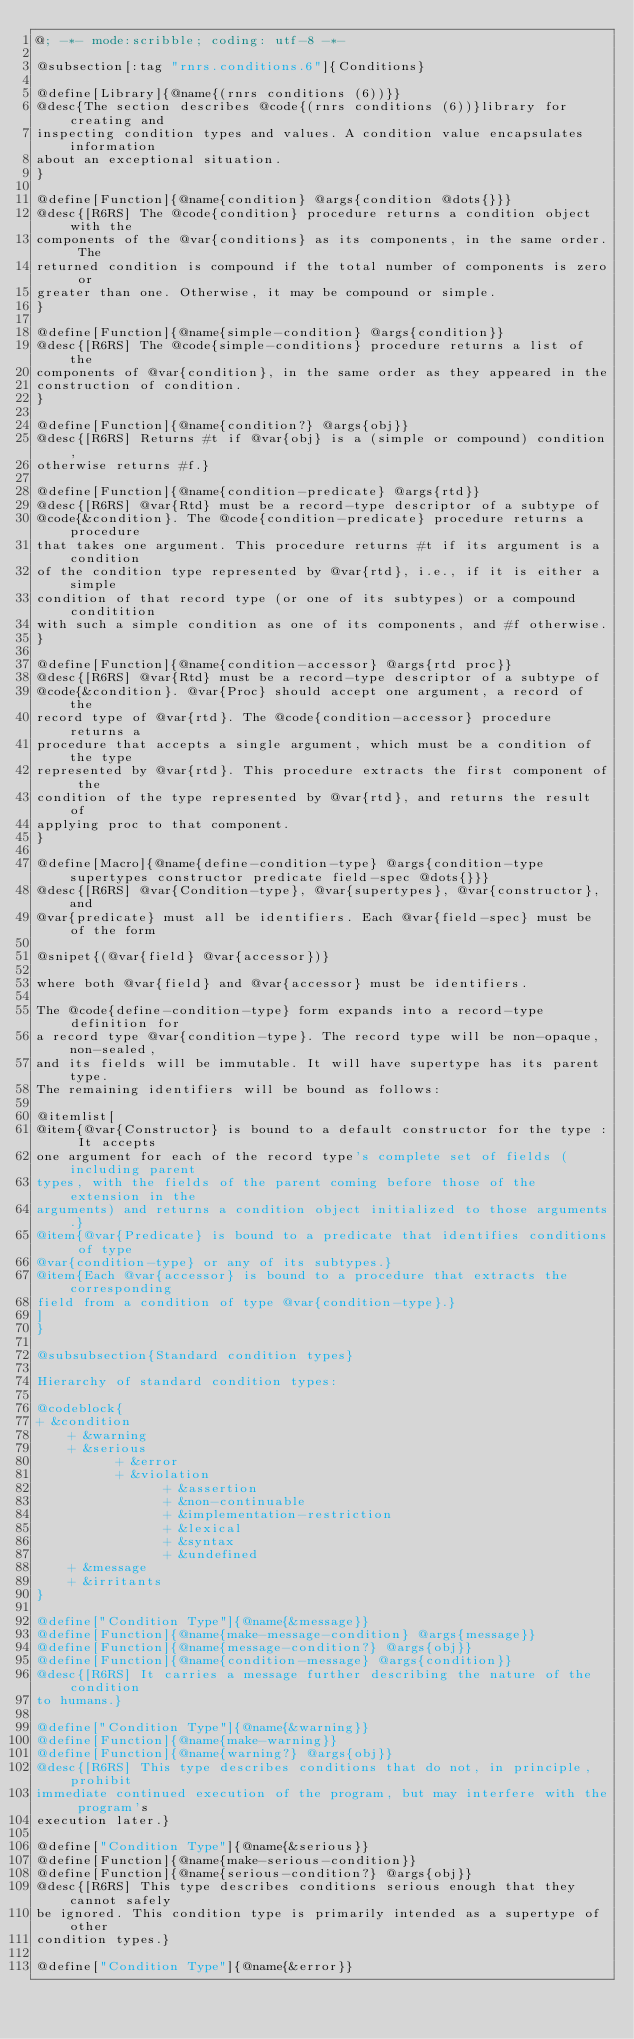<code> <loc_0><loc_0><loc_500><loc_500><_Racket_>@; -*- mode:scribble; coding: utf-8 -*-

@subsection[:tag "rnrs.conditions.6"]{Conditions}

@define[Library]{@name{(rnrs conditions (6))}}
@desc{The section describes @code{(rnrs conditions (6))}library for creating and
inspecting condition types and values. A condition value encapsulates information
about an exceptional situation.
}

@define[Function]{@name{condition} @args{condition @dots{}}}
@desc{[R6RS] The @code{condition} procedure returns a condition object with the
components of the @var{conditions} as its components, in the same order. The
returned condition is compound if the total number of components is zero or
greater than one. Otherwise, it may be compound or simple.
}

@define[Function]{@name{simple-condition} @args{condition}}
@desc{[R6RS] The @code{simple-conditions} procedure returns a list of the
components of @var{condition}, in the same order as they appeared in the
construction of condition.
}

@define[Function]{@name{condition?} @args{obj}}
@desc{[R6RS] Returns #t if @var{obj} is a (simple or compound) condition,
otherwise returns #f.}

@define[Function]{@name{condition-predicate} @args{rtd}}
@desc{[R6RS] @var{Rtd} must be a record-type descriptor of a subtype of
@code{&condition}. The @code{condition-predicate} procedure returns a procedure
that takes one argument. This procedure returns #t if its argument is a condition
of the condition type represented by @var{rtd}, i.e., if it is either a simple
condition of that record type (or one of its subtypes) or a compound conditition
with such a simple condition as one of its components, and #f otherwise.
}

@define[Function]{@name{condition-accessor} @args{rtd proc}}
@desc{[R6RS] @var{Rtd} must be a record-type descriptor of a subtype of
@code{&condition}. @var{Proc} should accept one argument, a record of the
record type of @var{rtd}. The @code{condition-accessor} procedure returns a
procedure that accepts a single argument, which must be a condition of the type
represented by @var{rtd}. This procedure extracts the first component of the
condition of the type represented by @var{rtd}, and returns the result of
applying proc to that component.
}

@define[Macro]{@name{define-condition-type} @args{condition-type supertypes constructor predicate field-spec @dots{}}}
@desc{[R6RS] @var{Condition-type}, @var{supertypes}, @var{constructor}, and 
@var{predicate} must all be identifiers. Each @var{field-spec} must be of the form

@snipet{(@var{field} @var{accessor})}

where both @var{field} and @var{accessor} must be identifiers.

The @code{define-condition-type} form expands into a record-type definition for
a record type @var{condition-type}. The record type will be non-opaque, non-sealed,
and its fields will be immutable. It will have supertype has its parent type.
The remaining identifiers will be bound as follows:

@itemlist[
@item{@var{Constructor} is bound to a default constructor for the type : It accepts
one argument for each of the record type's complete set of fields (including parent
types, with the fields of the parent coming before those of the extension in the
arguments) and returns a condition object initialized to those arguments.}
@item{@var{Predicate} is bound to a predicate that identifies conditions of type
@var{condition-type} or any of its subtypes.}
@item{Each @var{accessor} is bound to a procedure that extracts the corresponding
field from a condition of type @var{condition-type}.}
]
}

@subsubsection{Standard condition types}

Hierarchy of standard condition types:

@codeblock{
+ &condition
    + &warning
    + &serious
          + &error
          + &violation
                + &assertion
                + &non-continuable
                + &implementation-restriction
                + &lexical
                + &syntax
                + &undefined
    + &message
    + &irritants
}

@define["Condition Type"]{@name{&message}}
@define[Function]{@name{make-message-condition} @args{message}}
@define[Function]{@name{message-condition?} @args{obj}}
@define[Function]{@name{condition-message} @args{condition}}
@desc{[R6RS] It carries a message further describing the nature of the condition
to humans.}

@define["Condition Type"]{@name{&warning}}
@define[Function]{@name{make-warning}}
@define[Function]{@name{warning?} @args{obj}}
@desc{[R6RS] This type describes conditions that do not, in principle, prohibit
immediate continued execution of the program, but may interfere with the program's
execution later.}

@define["Condition Type"]{@name{&serious}}
@define[Function]{@name{make-serious-condition}}
@define[Function]{@name{serious-condition?} @args{obj}}
@desc{[R6RS] This type describes conditions serious enough that they cannot safely
be ignored. This condition type is primarily intended as a supertype of other
condition types.}

@define["Condition Type"]{@name{&error}}</code> 